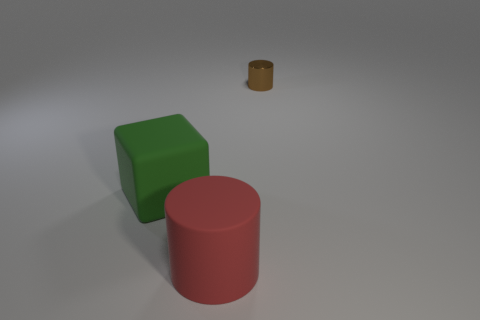Add 2 green rubber objects. How many objects exist? 5 Subtract all small brown shiny cylinders. Subtract all metal objects. How many objects are left? 1 Add 1 big red objects. How many big red objects are left? 2 Add 2 red rubber cylinders. How many red rubber cylinders exist? 3 Subtract 1 red cylinders. How many objects are left? 2 Subtract all cylinders. How many objects are left? 1 